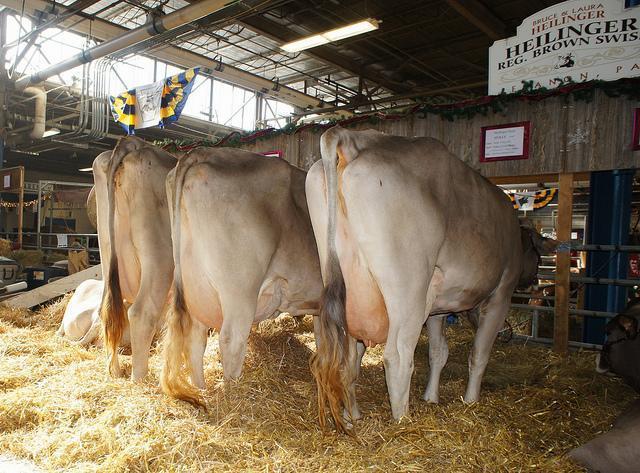How many cows are in the picture?
Give a very brief answer. 4. 